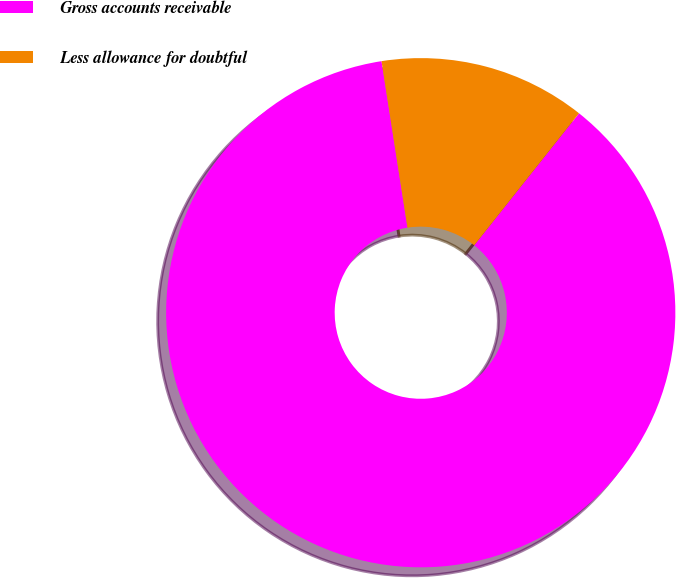Convert chart. <chart><loc_0><loc_0><loc_500><loc_500><pie_chart><fcel>Gross accounts receivable<fcel>Less allowance for doubtful<nl><fcel>86.86%<fcel>13.14%<nl></chart> 